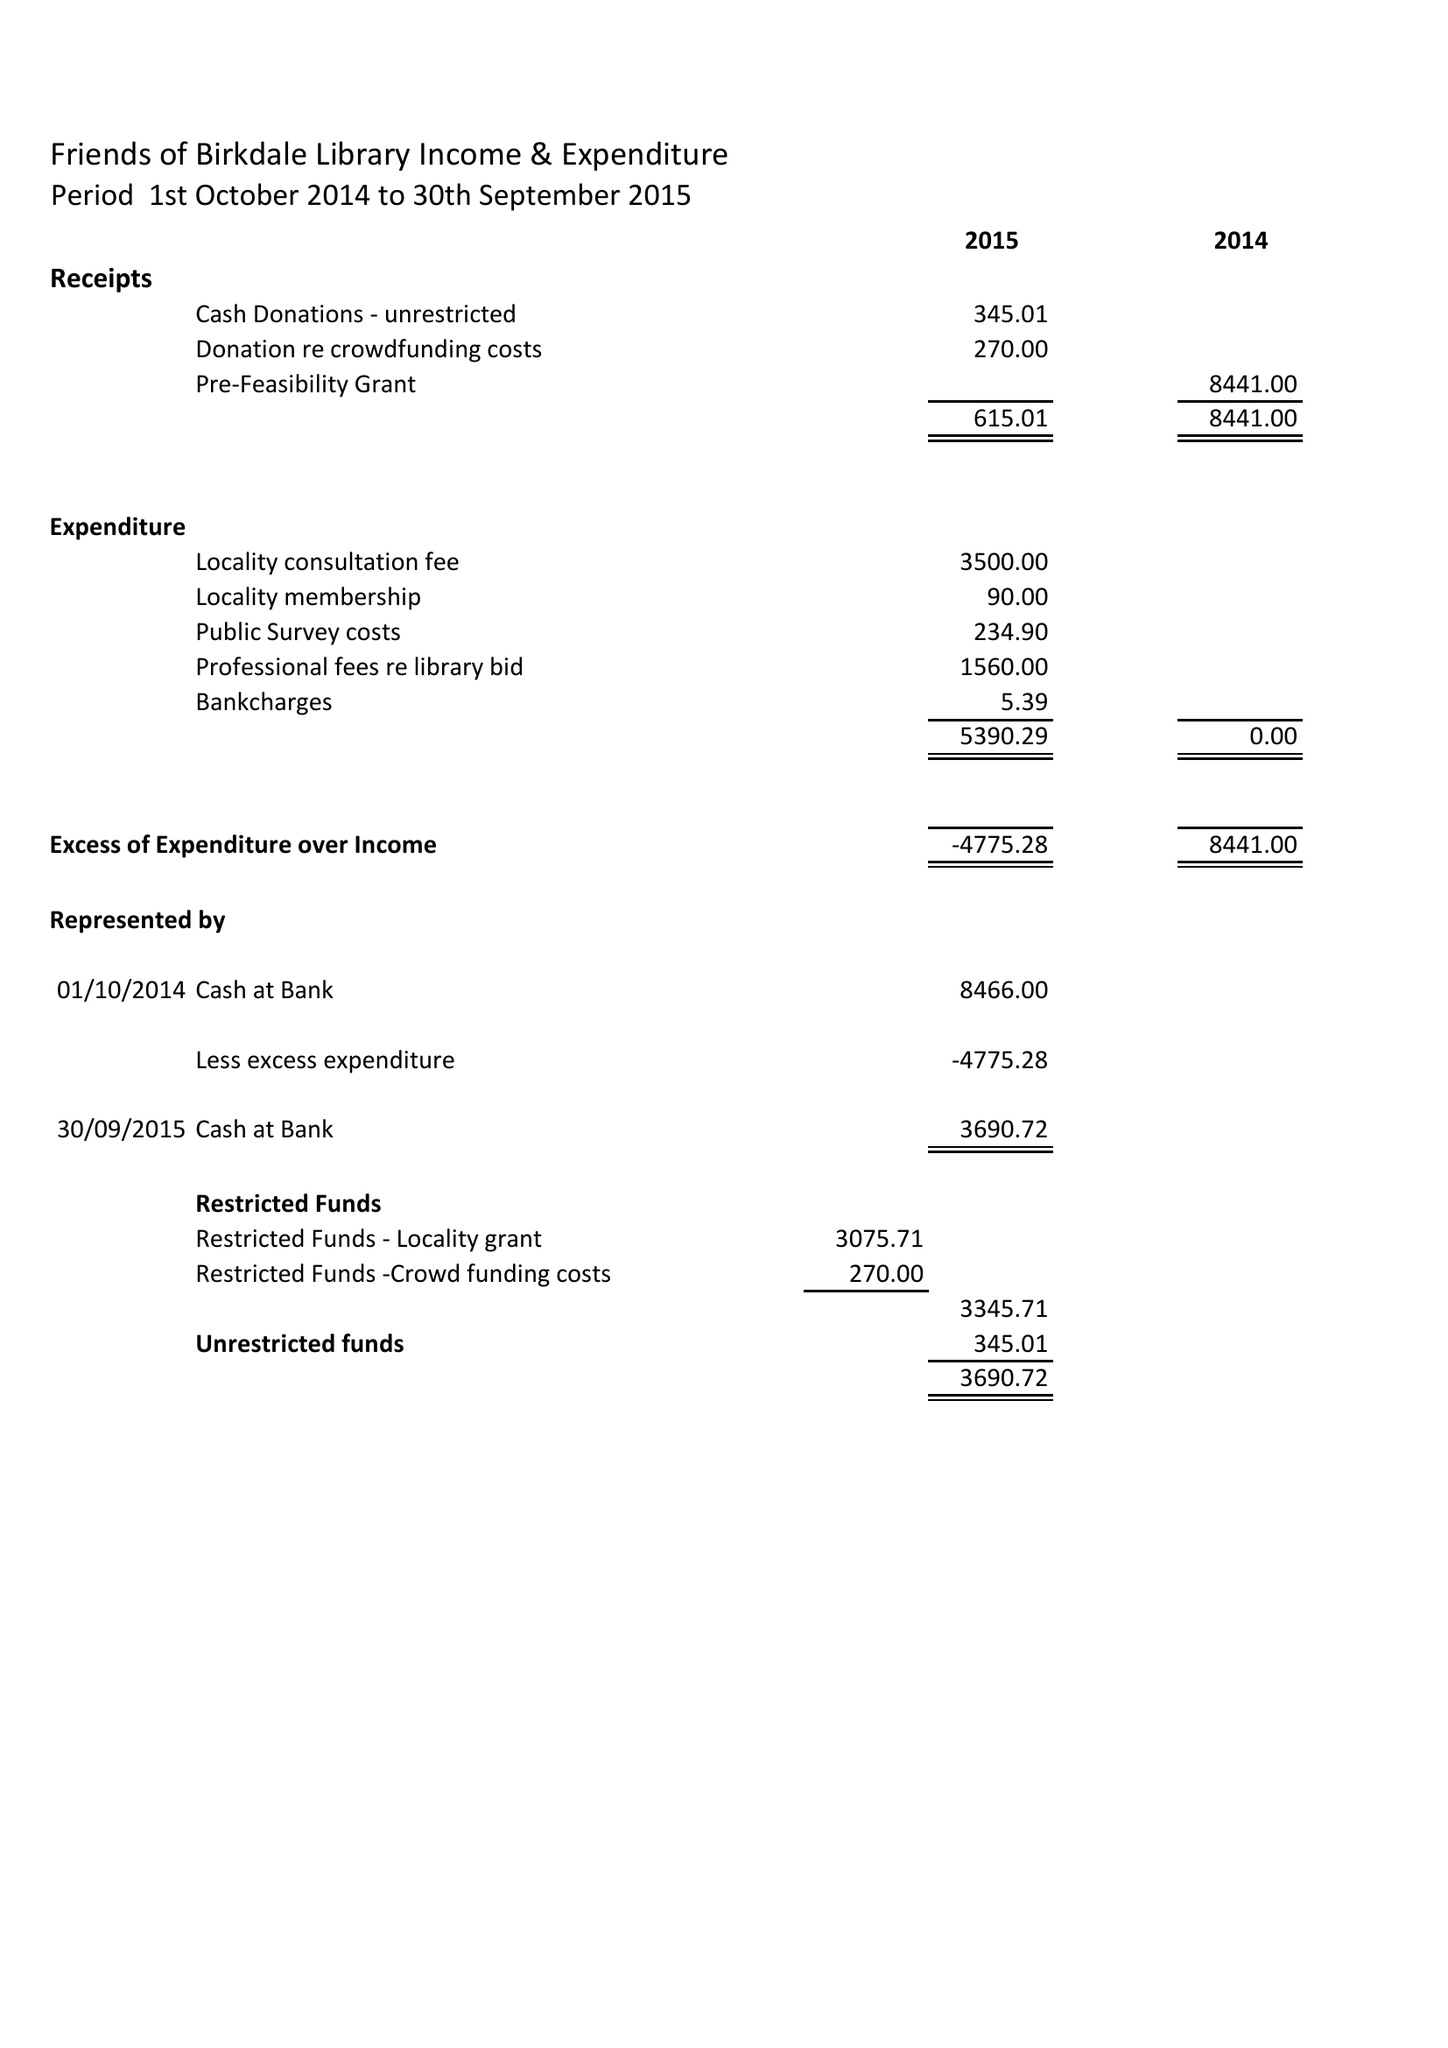What is the value for the address__street_line?
Answer the question using a single word or phrase. None 